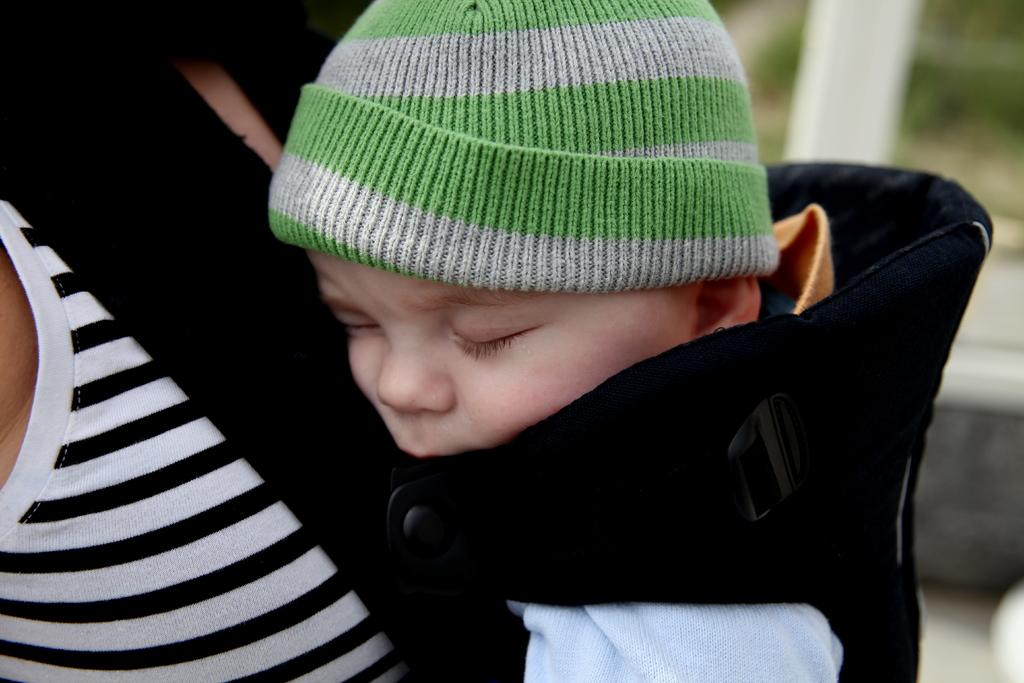What is the main subject of the image? There is a baby in the image. How is the baby being carried in the image? The baby is in a baby carrier. Who is supporting the baby carrier in the image? The baby carrier is resting on a woman. How many apples can be seen in the image? There are no apples present in the image. What type of car is visible in the image? There is no car present in the image. 